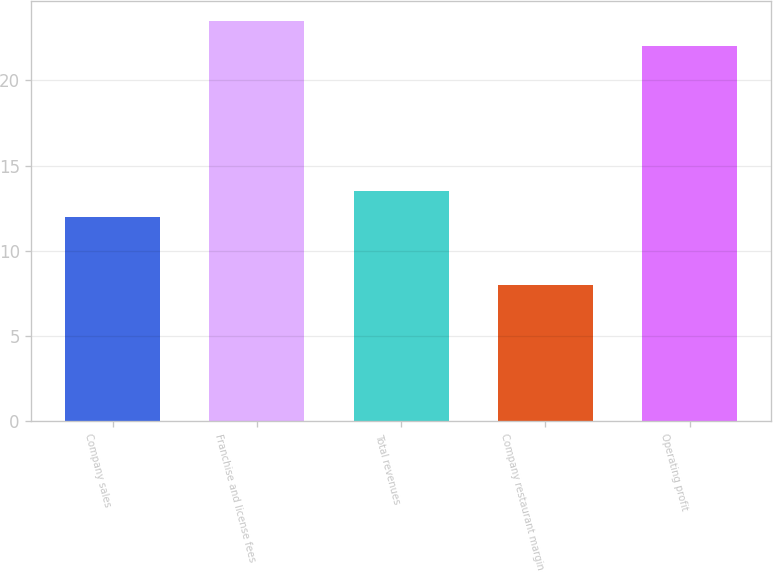Convert chart. <chart><loc_0><loc_0><loc_500><loc_500><bar_chart><fcel>Company sales<fcel>Franchise and license fees<fcel>Total revenues<fcel>Company restaurant margin<fcel>Operating profit<nl><fcel>12<fcel>23.5<fcel>13.5<fcel>8<fcel>22<nl></chart> 